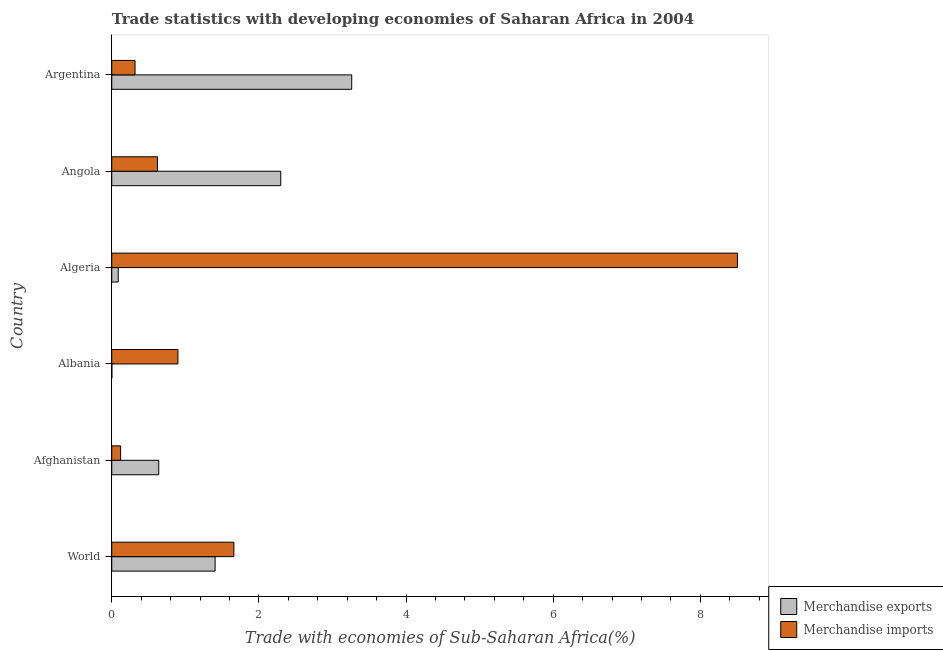Are the number of bars per tick equal to the number of legend labels?
Provide a succinct answer. Yes. Are the number of bars on each tick of the Y-axis equal?
Keep it short and to the point. Yes. How many bars are there on the 2nd tick from the top?
Offer a very short reply. 2. How many bars are there on the 4th tick from the bottom?
Offer a very short reply. 2. What is the label of the 3rd group of bars from the top?
Keep it short and to the point. Algeria. What is the merchandise exports in Albania?
Make the answer very short. 0. Across all countries, what is the maximum merchandise imports?
Make the answer very short. 8.5. Across all countries, what is the minimum merchandise imports?
Offer a very short reply. 0.12. In which country was the merchandise imports minimum?
Keep it short and to the point. Afghanistan. What is the total merchandise imports in the graph?
Provide a succinct answer. 12.12. What is the difference between the merchandise exports in Afghanistan and that in Algeria?
Offer a terse response. 0.55. What is the difference between the merchandise imports in Angola and the merchandise exports in Albania?
Keep it short and to the point. 0.62. What is the average merchandise exports per country?
Give a very brief answer. 1.28. What is the difference between the merchandise imports and merchandise exports in Angola?
Your response must be concise. -1.68. In how many countries, is the merchandise imports greater than 5.6 %?
Offer a terse response. 1. What is the ratio of the merchandise exports in Afghanistan to that in Albania?
Ensure brevity in your answer.  395.06. Is the difference between the merchandise exports in Afghanistan and Angola greater than the difference between the merchandise imports in Afghanistan and Angola?
Provide a succinct answer. No. What is the difference between the highest and the second highest merchandise imports?
Your answer should be compact. 6.84. What is the difference between the highest and the lowest merchandise exports?
Make the answer very short. 3.26. Is the sum of the merchandise exports in Afghanistan and Argentina greater than the maximum merchandise imports across all countries?
Give a very brief answer. No. Are the values on the major ticks of X-axis written in scientific E-notation?
Offer a very short reply. No. Does the graph contain any zero values?
Keep it short and to the point. No. Where does the legend appear in the graph?
Make the answer very short. Bottom right. How are the legend labels stacked?
Ensure brevity in your answer.  Vertical. What is the title of the graph?
Your response must be concise. Trade statistics with developing economies of Saharan Africa in 2004. Does "Investments" appear as one of the legend labels in the graph?
Offer a very short reply. No. What is the label or title of the X-axis?
Keep it short and to the point. Trade with economies of Sub-Saharan Africa(%). What is the Trade with economies of Sub-Saharan Africa(%) of Merchandise exports in World?
Make the answer very short. 1.4. What is the Trade with economies of Sub-Saharan Africa(%) of Merchandise imports in World?
Keep it short and to the point. 1.66. What is the Trade with economies of Sub-Saharan Africa(%) in Merchandise exports in Afghanistan?
Your response must be concise. 0.64. What is the Trade with economies of Sub-Saharan Africa(%) of Merchandise imports in Afghanistan?
Ensure brevity in your answer.  0.12. What is the Trade with economies of Sub-Saharan Africa(%) of Merchandise exports in Albania?
Offer a very short reply. 0. What is the Trade with economies of Sub-Saharan Africa(%) in Merchandise imports in Albania?
Give a very brief answer. 0.9. What is the Trade with economies of Sub-Saharan Africa(%) of Merchandise exports in Algeria?
Ensure brevity in your answer.  0.09. What is the Trade with economies of Sub-Saharan Africa(%) in Merchandise imports in Algeria?
Your answer should be compact. 8.5. What is the Trade with economies of Sub-Saharan Africa(%) of Merchandise exports in Angola?
Your answer should be very brief. 2.3. What is the Trade with economies of Sub-Saharan Africa(%) of Merchandise imports in Angola?
Your response must be concise. 0.62. What is the Trade with economies of Sub-Saharan Africa(%) in Merchandise exports in Argentina?
Your answer should be very brief. 3.26. What is the Trade with economies of Sub-Saharan Africa(%) of Merchandise imports in Argentina?
Your response must be concise. 0.32. Across all countries, what is the maximum Trade with economies of Sub-Saharan Africa(%) of Merchandise exports?
Give a very brief answer. 3.26. Across all countries, what is the maximum Trade with economies of Sub-Saharan Africa(%) in Merchandise imports?
Make the answer very short. 8.5. Across all countries, what is the minimum Trade with economies of Sub-Saharan Africa(%) of Merchandise exports?
Offer a very short reply. 0. Across all countries, what is the minimum Trade with economies of Sub-Saharan Africa(%) of Merchandise imports?
Keep it short and to the point. 0.12. What is the total Trade with economies of Sub-Saharan Africa(%) of Merchandise exports in the graph?
Your answer should be compact. 7.69. What is the total Trade with economies of Sub-Saharan Africa(%) in Merchandise imports in the graph?
Make the answer very short. 12.12. What is the difference between the Trade with economies of Sub-Saharan Africa(%) in Merchandise exports in World and that in Afghanistan?
Provide a short and direct response. 0.77. What is the difference between the Trade with economies of Sub-Saharan Africa(%) in Merchandise imports in World and that in Afghanistan?
Your answer should be compact. 1.54. What is the difference between the Trade with economies of Sub-Saharan Africa(%) in Merchandise exports in World and that in Albania?
Ensure brevity in your answer.  1.4. What is the difference between the Trade with economies of Sub-Saharan Africa(%) of Merchandise imports in World and that in Albania?
Give a very brief answer. 0.76. What is the difference between the Trade with economies of Sub-Saharan Africa(%) of Merchandise exports in World and that in Algeria?
Provide a succinct answer. 1.32. What is the difference between the Trade with economies of Sub-Saharan Africa(%) in Merchandise imports in World and that in Algeria?
Make the answer very short. -6.84. What is the difference between the Trade with economies of Sub-Saharan Africa(%) of Merchandise exports in World and that in Angola?
Your response must be concise. -0.89. What is the difference between the Trade with economies of Sub-Saharan Africa(%) of Merchandise imports in World and that in Angola?
Offer a terse response. 1.04. What is the difference between the Trade with economies of Sub-Saharan Africa(%) of Merchandise exports in World and that in Argentina?
Provide a succinct answer. -1.86. What is the difference between the Trade with economies of Sub-Saharan Africa(%) of Merchandise imports in World and that in Argentina?
Give a very brief answer. 1.34. What is the difference between the Trade with economies of Sub-Saharan Africa(%) in Merchandise exports in Afghanistan and that in Albania?
Your answer should be very brief. 0.64. What is the difference between the Trade with economies of Sub-Saharan Africa(%) of Merchandise imports in Afghanistan and that in Albania?
Offer a terse response. -0.78. What is the difference between the Trade with economies of Sub-Saharan Africa(%) in Merchandise exports in Afghanistan and that in Algeria?
Provide a succinct answer. 0.55. What is the difference between the Trade with economies of Sub-Saharan Africa(%) of Merchandise imports in Afghanistan and that in Algeria?
Your answer should be compact. -8.38. What is the difference between the Trade with economies of Sub-Saharan Africa(%) in Merchandise exports in Afghanistan and that in Angola?
Give a very brief answer. -1.66. What is the difference between the Trade with economies of Sub-Saharan Africa(%) of Merchandise imports in Afghanistan and that in Angola?
Offer a terse response. -0.5. What is the difference between the Trade with economies of Sub-Saharan Africa(%) of Merchandise exports in Afghanistan and that in Argentina?
Offer a very short reply. -2.62. What is the difference between the Trade with economies of Sub-Saharan Africa(%) of Merchandise imports in Afghanistan and that in Argentina?
Keep it short and to the point. -0.2. What is the difference between the Trade with economies of Sub-Saharan Africa(%) of Merchandise exports in Albania and that in Algeria?
Your answer should be compact. -0.09. What is the difference between the Trade with economies of Sub-Saharan Africa(%) of Merchandise imports in Albania and that in Algeria?
Your response must be concise. -7.6. What is the difference between the Trade with economies of Sub-Saharan Africa(%) in Merchandise exports in Albania and that in Angola?
Make the answer very short. -2.29. What is the difference between the Trade with economies of Sub-Saharan Africa(%) of Merchandise imports in Albania and that in Angola?
Your answer should be compact. 0.28. What is the difference between the Trade with economies of Sub-Saharan Africa(%) in Merchandise exports in Albania and that in Argentina?
Provide a short and direct response. -3.26. What is the difference between the Trade with economies of Sub-Saharan Africa(%) in Merchandise imports in Albania and that in Argentina?
Ensure brevity in your answer.  0.58. What is the difference between the Trade with economies of Sub-Saharan Africa(%) of Merchandise exports in Algeria and that in Angola?
Make the answer very short. -2.21. What is the difference between the Trade with economies of Sub-Saharan Africa(%) in Merchandise imports in Algeria and that in Angola?
Give a very brief answer. 7.88. What is the difference between the Trade with economies of Sub-Saharan Africa(%) in Merchandise exports in Algeria and that in Argentina?
Provide a succinct answer. -3.17. What is the difference between the Trade with economies of Sub-Saharan Africa(%) of Merchandise imports in Algeria and that in Argentina?
Ensure brevity in your answer.  8.19. What is the difference between the Trade with economies of Sub-Saharan Africa(%) of Merchandise exports in Angola and that in Argentina?
Offer a very short reply. -0.96. What is the difference between the Trade with economies of Sub-Saharan Africa(%) in Merchandise imports in Angola and that in Argentina?
Offer a very short reply. 0.31. What is the difference between the Trade with economies of Sub-Saharan Africa(%) of Merchandise exports in World and the Trade with economies of Sub-Saharan Africa(%) of Merchandise imports in Afghanistan?
Make the answer very short. 1.28. What is the difference between the Trade with economies of Sub-Saharan Africa(%) in Merchandise exports in World and the Trade with economies of Sub-Saharan Africa(%) in Merchandise imports in Albania?
Give a very brief answer. 0.51. What is the difference between the Trade with economies of Sub-Saharan Africa(%) in Merchandise exports in World and the Trade with economies of Sub-Saharan Africa(%) in Merchandise imports in Algeria?
Your answer should be very brief. -7.1. What is the difference between the Trade with economies of Sub-Saharan Africa(%) in Merchandise exports in World and the Trade with economies of Sub-Saharan Africa(%) in Merchandise imports in Angola?
Ensure brevity in your answer.  0.78. What is the difference between the Trade with economies of Sub-Saharan Africa(%) of Merchandise exports in World and the Trade with economies of Sub-Saharan Africa(%) of Merchandise imports in Argentina?
Make the answer very short. 1.09. What is the difference between the Trade with economies of Sub-Saharan Africa(%) of Merchandise exports in Afghanistan and the Trade with economies of Sub-Saharan Africa(%) of Merchandise imports in Albania?
Ensure brevity in your answer.  -0.26. What is the difference between the Trade with economies of Sub-Saharan Africa(%) in Merchandise exports in Afghanistan and the Trade with economies of Sub-Saharan Africa(%) in Merchandise imports in Algeria?
Your answer should be very brief. -7.86. What is the difference between the Trade with economies of Sub-Saharan Africa(%) of Merchandise exports in Afghanistan and the Trade with economies of Sub-Saharan Africa(%) of Merchandise imports in Angola?
Your answer should be very brief. 0.02. What is the difference between the Trade with economies of Sub-Saharan Africa(%) in Merchandise exports in Afghanistan and the Trade with economies of Sub-Saharan Africa(%) in Merchandise imports in Argentina?
Your answer should be very brief. 0.32. What is the difference between the Trade with economies of Sub-Saharan Africa(%) of Merchandise exports in Albania and the Trade with economies of Sub-Saharan Africa(%) of Merchandise imports in Algeria?
Keep it short and to the point. -8.5. What is the difference between the Trade with economies of Sub-Saharan Africa(%) of Merchandise exports in Albania and the Trade with economies of Sub-Saharan Africa(%) of Merchandise imports in Angola?
Make the answer very short. -0.62. What is the difference between the Trade with economies of Sub-Saharan Africa(%) of Merchandise exports in Albania and the Trade with economies of Sub-Saharan Africa(%) of Merchandise imports in Argentina?
Your answer should be compact. -0.32. What is the difference between the Trade with economies of Sub-Saharan Africa(%) of Merchandise exports in Algeria and the Trade with economies of Sub-Saharan Africa(%) of Merchandise imports in Angola?
Provide a succinct answer. -0.53. What is the difference between the Trade with economies of Sub-Saharan Africa(%) in Merchandise exports in Algeria and the Trade with economies of Sub-Saharan Africa(%) in Merchandise imports in Argentina?
Your response must be concise. -0.23. What is the difference between the Trade with economies of Sub-Saharan Africa(%) in Merchandise exports in Angola and the Trade with economies of Sub-Saharan Africa(%) in Merchandise imports in Argentina?
Offer a terse response. 1.98. What is the average Trade with economies of Sub-Saharan Africa(%) in Merchandise exports per country?
Give a very brief answer. 1.28. What is the average Trade with economies of Sub-Saharan Africa(%) in Merchandise imports per country?
Your answer should be very brief. 2.02. What is the difference between the Trade with economies of Sub-Saharan Africa(%) in Merchandise exports and Trade with economies of Sub-Saharan Africa(%) in Merchandise imports in World?
Provide a short and direct response. -0.25. What is the difference between the Trade with economies of Sub-Saharan Africa(%) of Merchandise exports and Trade with economies of Sub-Saharan Africa(%) of Merchandise imports in Afghanistan?
Your response must be concise. 0.52. What is the difference between the Trade with economies of Sub-Saharan Africa(%) in Merchandise exports and Trade with economies of Sub-Saharan Africa(%) in Merchandise imports in Albania?
Your answer should be compact. -0.9. What is the difference between the Trade with economies of Sub-Saharan Africa(%) of Merchandise exports and Trade with economies of Sub-Saharan Africa(%) of Merchandise imports in Algeria?
Provide a succinct answer. -8.42. What is the difference between the Trade with economies of Sub-Saharan Africa(%) of Merchandise exports and Trade with economies of Sub-Saharan Africa(%) of Merchandise imports in Angola?
Your response must be concise. 1.67. What is the difference between the Trade with economies of Sub-Saharan Africa(%) in Merchandise exports and Trade with economies of Sub-Saharan Africa(%) in Merchandise imports in Argentina?
Give a very brief answer. 2.94. What is the ratio of the Trade with economies of Sub-Saharan Africa(%) of Merchandise exports in World to that in Afghanistan?
Offer a terse response. 2.2. What is the ratio of the Trade with economies of Sub-Saharan Africa(%) of Merchandise imports in World to that in Afghanistan?
Make the answer very short. 13.74. What is the ratio of the Trade with economies of Sub-Saharan Africa(%) in Merchandise exports in World to that in Albania?
Offer a very short reply. 869.2. What is the ratio of the Trade with economies of Sub-Saharan Africa(%) of Merchandise imports in World to that in Albania?
Your answer should be compact. 1.85. What is the ratio of the Trade with economies of Sub-Saharan Africa(%) in Merchandise exports in World to that in Algeria?
Provide a short and direct response. 15.99. What is the ratio of the Trade with economies of Sub-Saharan Africa(%) of Merchandise imports in World to that in Algeria?
Your response must be concise. 0.2. What is the ratio of the Trade with economies of Sub-Saharan Africa(%) of Merchandise exports in World to that in Angola?
Keep it short and to the point. 0.61. What is the ratio of the Trade with economies of Sub-Saharan Africa(%) in Merchandise imports in World to that in Angola?
Your response must be concise. 2.67. What is the ratio of the Trade with economies of Sub-Saharan Africa(%) of Merchandise exports in World to that in Argentina?
Your answer should be very brief. 0.43. What is the ratio of the Trade with economies of Sub-Saharan Africa(%) in Merchandise imports in World to that in Argentina?
Provide a succinct answer. 5.24. What is the ratio of the Trade with economies of Sub-Saharan Africa(%) of Merchandise exports in Afghanistan to that in Albania?
Your answer should be very brief. 395.06. What is the ratio of the Trade with economies of Sub-Saharan Africa(%) in Merchandise imports in Afghanistan to that in Albania?
Provide a short and direct response. 0.13. What is the ratio of the Trade with economies of Sub-Saharan Africa(%) in Merchandise exports in Afghanistan to that in Algeria?
Give a very brief answer. 7.27. What is the ratio of the Trade with economies of Sub-Saharan Africa(%) in Merchandise imports in Afghanistan to that in Algeria?
Your response must be concise. 0.01. What is the ratio of the Trade with economies of Sub-Saharan Africa(%) in Merchandise exports in Afghanistan to that in Angola?
Offer a terse response. 0.28. What is the ratio of the Trade with economies of Sub-Saharan Africa(%) in Merchandise imports in Afghanistan to that in Angola?
Ensure brevity in your answer.  0.19. What is the ratio of the Trade with economies of Sub-Saharan Africa(%) in Merchandise exports in Afghanistan to that in Argentina?
Offer a very short reply. 0.2. What is the ratio of the Trade with economies of Sub-Saharan Africa(%) in Merchandise imports in Afghanistan to that in Argentina?
Ensure brevity in your answer.  0.38. What is the ratio of the Trade with economies of Sub-Saharan Africa(%) of Merchandise exports in Albania to that in Algeria?
Your answer should be compact. 0.02. What is the ratio of the Trade with economies of Sub-Saharan Africa(%) in Merchandise imports in Albania to that in Algeria?
Your answer should be compact. 0.11. What is the ratio of the Trade with economies of Sub-Saharan Africa(%) in Merchandise exports in Albania to that in Angola?
Provide a short and direct response. 0. What is the ratio of the Trade with economies of Sub-Saharan Africa(%) in Merchandise imports in Albania to that in Angola?
Offer a very short reply. 1.45. What is the ratio of the Trade with economies of Sub-Saharan Africa(%) in Merchandise imports in Albania to that in Argentina?
Your answer should be compact. 2.84. What is the ratio of the Trade with economies of Sub-Saharan Africa(%) of Merchandise exports in Algeria to that in Angola?
Provide a short and direct response. 0.04. What is the ratio of the Trade with economies of Sub-Saharan Africa(%) in Merchandise imports in Algeria to that in Angola?
Keep it short and to the point. 13.67. What is the ratio of the Trade with economies of Sub-Saharan Africa(%) in Merchandise exports in Algeria to that in Argentina?
Your answer should be compact. 0.03. What is the ratio of the Trade with economies of Sub-Saharan Africa(%) in Merchandise imports in Algeria to that in Argentina?
Keep it short and to the point. 26.86. What is the ratio of the Trade with economies of Sub-Saharan Africa(%) in Merchandise exports in Angola to that in Argentina?
Your answer should be compact. 0.7. What is the ratio of the Trade with economies of Sub-Saharan Africa(%) in Merchandise imports in Angola to that in Argentina?
Keep it short and to the point. 1.96. What is the difference between the highest and the second highest Trade with economies of Sub-Saharan Africa(%) in Merchandise exports?
Make the answer very short. 0.96. What is the difference between the highest and the second highest Trade with economies of Sub-Saharan Africa(%) in Merchandise imports?
Keep it short and to the point. 6.84. What is the difference between the highest and the lowest Trade with economies of Sub-Saharan Africa(%) of Merchandise exports?
Give a very brief answer. 3.26. What is the difference between the highest and the lowest Trade with economies of Sub-Saharan Africa(%) in Merchandise imports?
Provide a short and direct response. 8.38. 